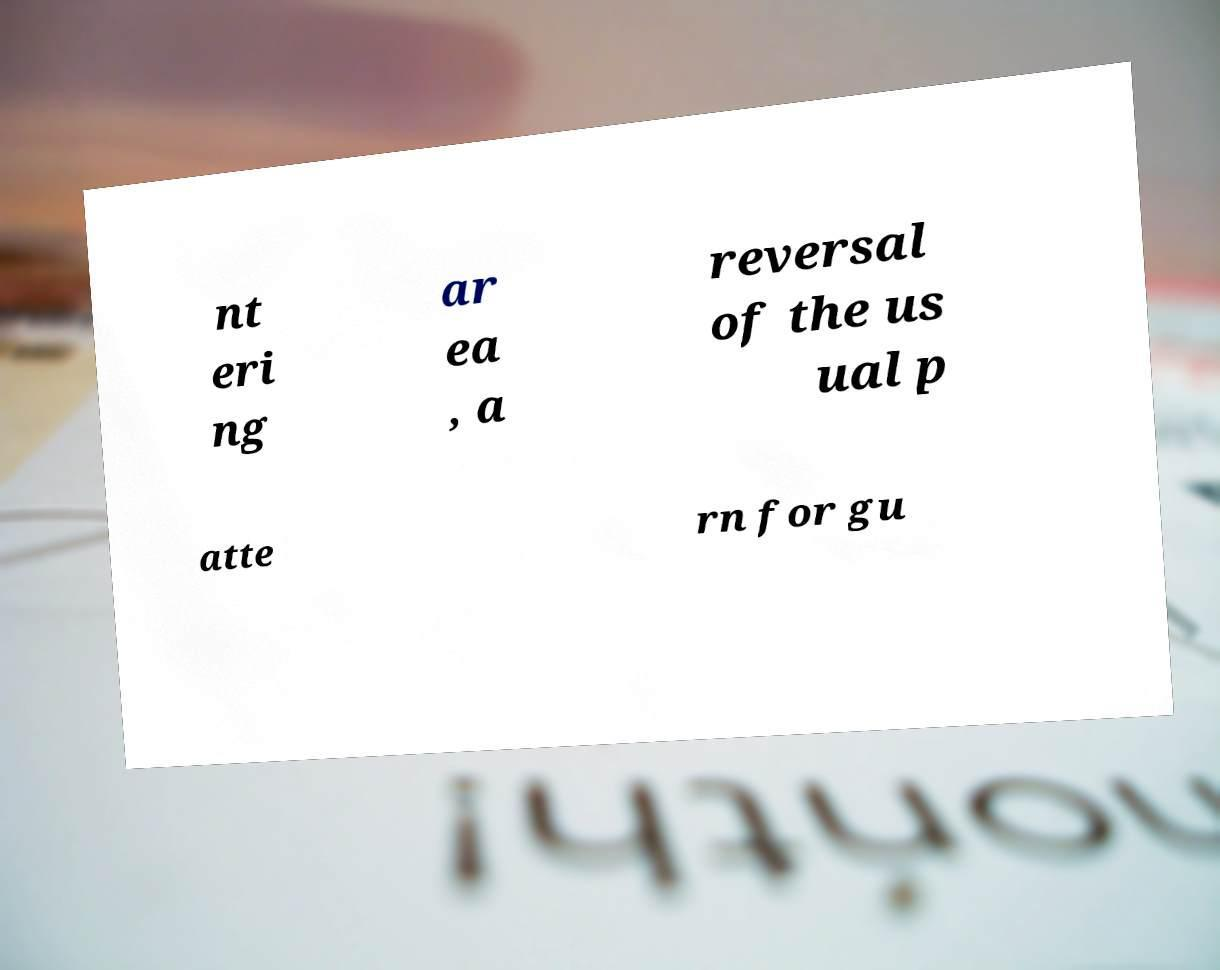Could you extract and type out the text from this image? nt eri ng ar ea , a reversal of the us ual p atte rn for gu 